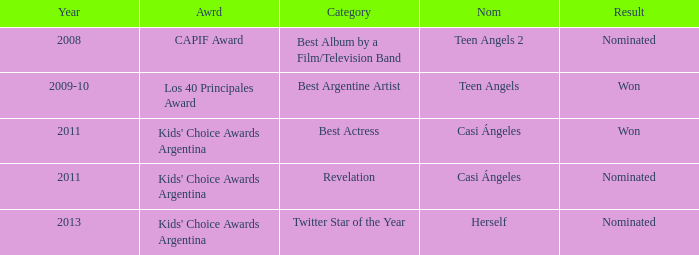What year saw an award in the category of Revelation? 2011.0. 